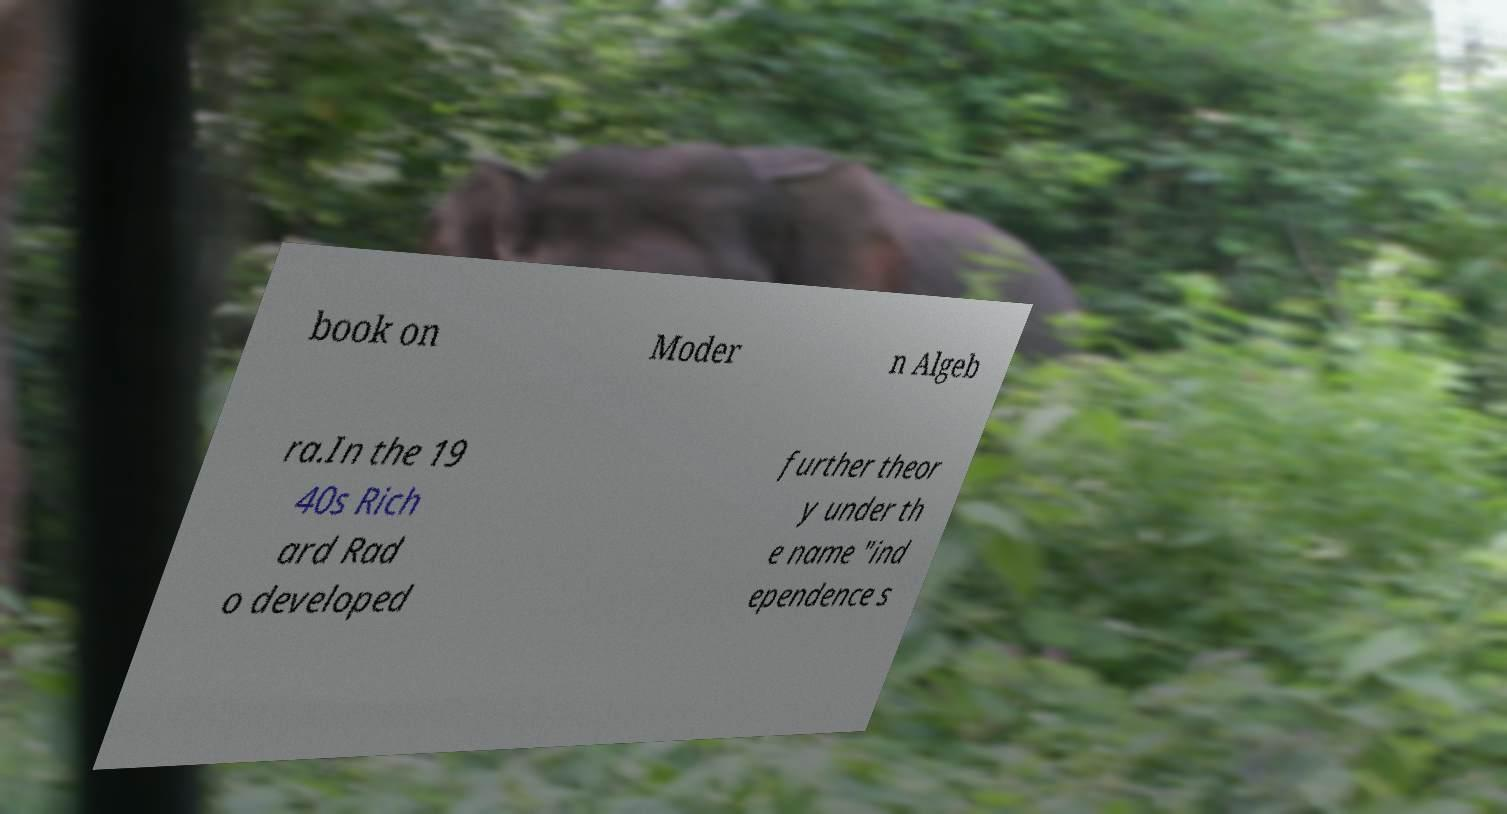Could you assist in decoding the text presented in this image and type it out clearly? book on Moder n Algeb ra.In the 19 40s Rich ard Rad o developed further theor y under th e name "ind ependence s 